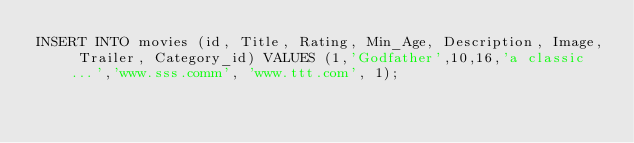<code> <loc_0><loc_0><loc_500><loc_500><_SQL_>INSERT INTO movies (id, Title, Rating, Min_Age, Description, Image, Trailer, Category_id) VALUES (1,'Godfather',10,16,'a classic...','www.sss.comm', 'www.ttt.com', 1);</code> 